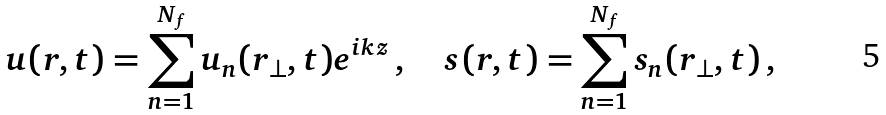Convert formula to latex. <formula><loc_0><loc_0><loc_500><loc_500>u ( { r } , t ) = \sum _ { n = 1 } ^ { N _ { f } } u _ { n } ( r _ { \bot } , t ) e ^ { i k z } \, , \quad s ( { r } , t ) = \sum _ { n = 1 } ^ { N _ { f } } s _ { n } ( r _ { \bot } , t ) \, ,</formula> 